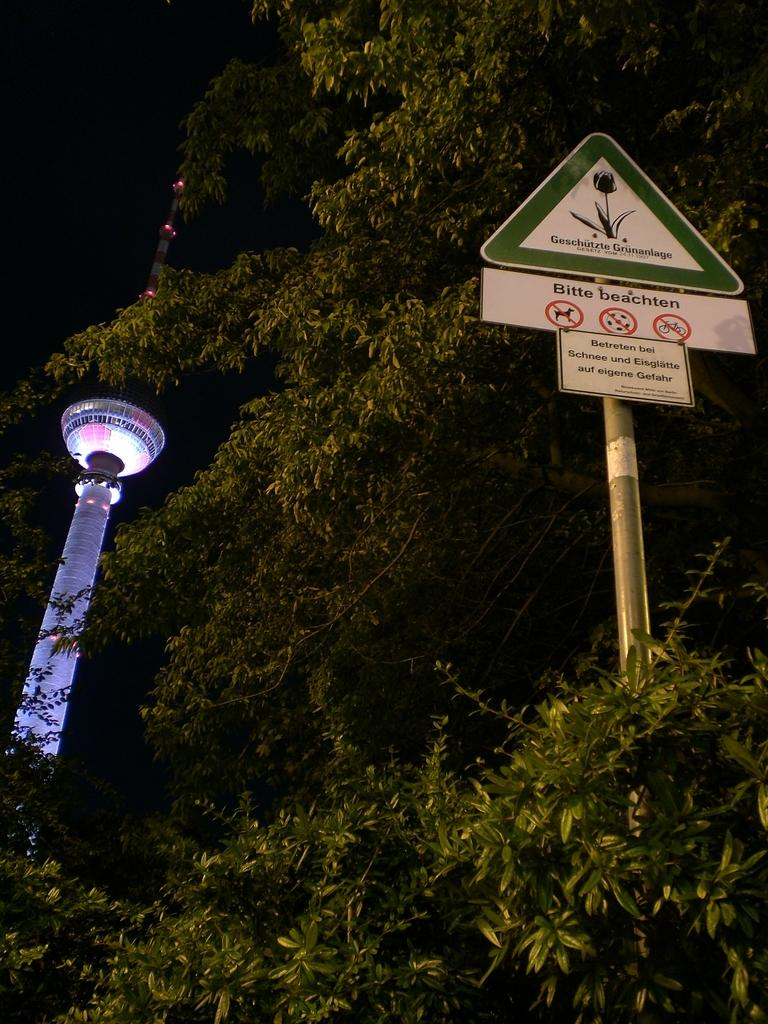What is the main structure in the image? There is a tower in the image. What type of vegetation can be seen in the image? There are trees in the image. What else is present in the image besides the tower and trees? There is a pole with boards in the image. How would you describe the background behind the tower? The background behind the tower is dark. Can you tell me how many kettles are hanging from the pole in the image? There are no kettles present in the image; it features a tower, trees, and a pole with boards. Is there an umbrella being used as a prop in the image? There is no umbrella present in the image. 